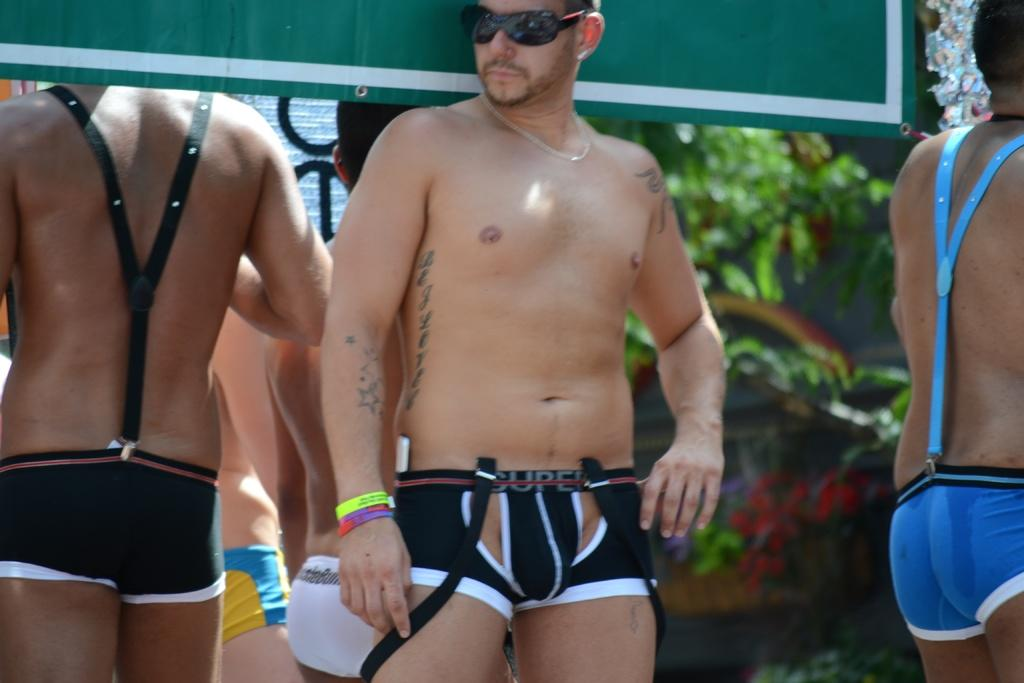What is happening in the image? There are people standing in the image. What can be seen in the background of the image? There are leaves and some objects in the background of the image. How would you describe the quality of the image? The image is blurry. What type of pancake is being flipped in the image? There is no pancake present in the image. What material are the objects in the background made of? The provided facts do not specify the material of the objects in the background. 